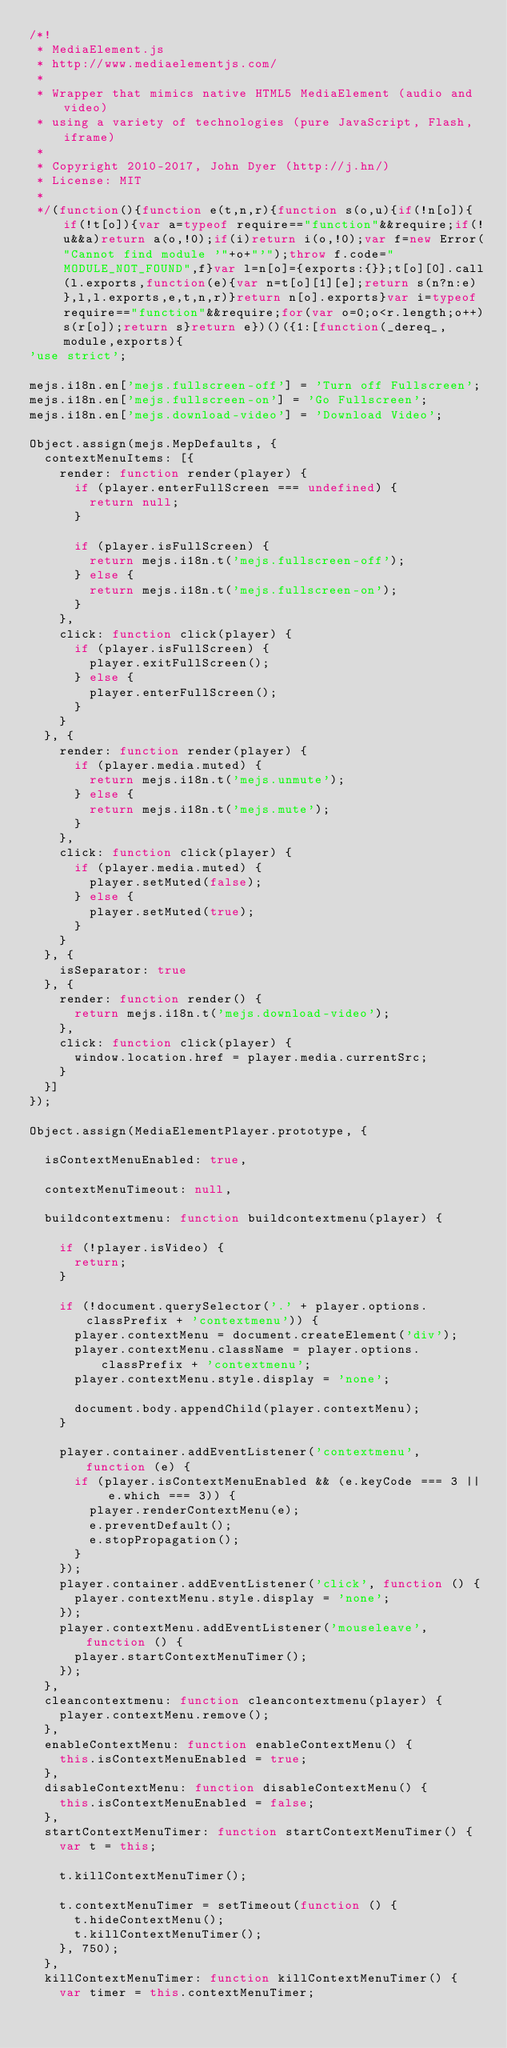<code> <loc_0><loc_0><loc_500><loc_500><_JavaScript_>/*!
 * MediaElement.js
 * http://www.mediaelementjs.com/
 *
 * Wrapper that mimics native HTML5 MediaElement (audio and video)
 * using a variety of technologies (pure JavaScript, Flash, iframe)
 *
 * Copyright 2010-2017, John Dyer (http://j.hn/)
 * License: MIT
 *
 */(function(){function e(t,n,r){function s(o,u){if(!n[o]){if(!t[o]){var a=typeof require=="function"&&require;if(!u&&a)return a(o,!0);if(i)return i(o,!0);var f=new Error("Cannot find module '"+o+"'");throw f.code="MODULE_NOT_FOUND",f}var l=n[o]={exports:{}};t[o][0].call(l.exports,function(e){var n=t[o][1][e];return s(n?n:e)},l,l.exports,e,t,n,r)}return n[o].exports}var i=typeof require=="function"&&require;for(var o=0;o<r.length;o++)s(r[o]);return s}return e})()({1:[function(_dereq_,module,exports){
'use strict';

mejs.i18n.en['mejs.fullscreen-off'] = 'Turn off Fullscreen';
mejs.i18n.en['mejs.fullscreen-on'] = 'Go Fullscreen';
mejs.i18n.en['mejs.download-video'] = 'Download Video';

Object.assign(mejs.MepDefaults, {
	contextMenuItems: [{
		render: function render(player) {
			if (player.enterFullScreen === undefined) {
				return null;
			}

			if (player.isFullScreen) {
				return mejs.i18n.t('mejs.fullscreen-off');
			} else {
				return mejs.i18n.t('mejs.fullscreen-on');
			}
		},
		click: function click(player) {
			if (player.isFullScreen) {
				player.exitFullScreen();
			} else {
				player.enterFullScreen();
			}
		}
	}, {
		render: function render(player) {
			if (player.media.muted) {
				return mejs.i18n.t('mejs.unmute');
			} else {
				return mejs.i18n.t('mejs.mute');
			}
		},
		click: function click(player) {
			if (player.media.muted) {
				player.setMuted(false);
			} else {
				player.setMuted(true);
			}
		}
	}, {
		isSeparator: true
	}, {
		render: function render() {
			return mejs.i18n.t('mejs.download-video');
		},
		click: function click(player) {
			window.location.href = player.media.currentSrc;
		}
	}]
});

Object.assign(MediaElementPlayer.prototype, {

	isContextMenuEnabled: true,

	contextMenuTimeout: null,

	buildcontextmenu: function buildcontextmenu(player) {

		if (!player.isVideo) {
			return;
		}

		if (!document.querySelector('.' + player.options.classPrefix + 'contextmenu')) {
			player.contextMenu = document.createElement('div');
			player.contextMenu.className = player.options.classPrefix + 'contextmenu';
			player.contextMenu.style.display = 'none';

			document.body.appendChild(player.contextMenu);
		}

		player.container.addEventListener('contextmenu', function (e) {
			if (player.isContextMenuEnabled && (e.keyCode === 3 || e.which === 3)) {
				player.renderContextMenu(e);
				e.preventDefault();
				e.stopPropagation();
			}
		});
		player.container.addEventListener('click', function () {
			player.contextMenu.style.display = 'none';
		});
		player.contextMenu.addEventListener('mouseleave', function () {
			player.startContextMenuTimer();
		});
	},
	cleancontextmenu: function cleancontextmenu(player) {
		player.contextMenu.remove();
	},
	enableContextMenu: function enableContextMenu() {
		this.isContextMenuEnabled = true;
	},
	disableContextMenu: function disableContextMenu() {
		this.isContextMenuEnabled = false;
	},
	startContextMenuTimer: function startContextMenuTimer() {
		var t = this;

		t.killContextMenuTimer();

		t.contextMenuTimer = setTimeout(function () {
			t.hideContextMenu();
			t.killContextMenuTimer();
		}, 750);
	},
	killContextMenuTimer: function killContextMenuTimer() {
		var timer = this.contextMenuTimer;
</code> 